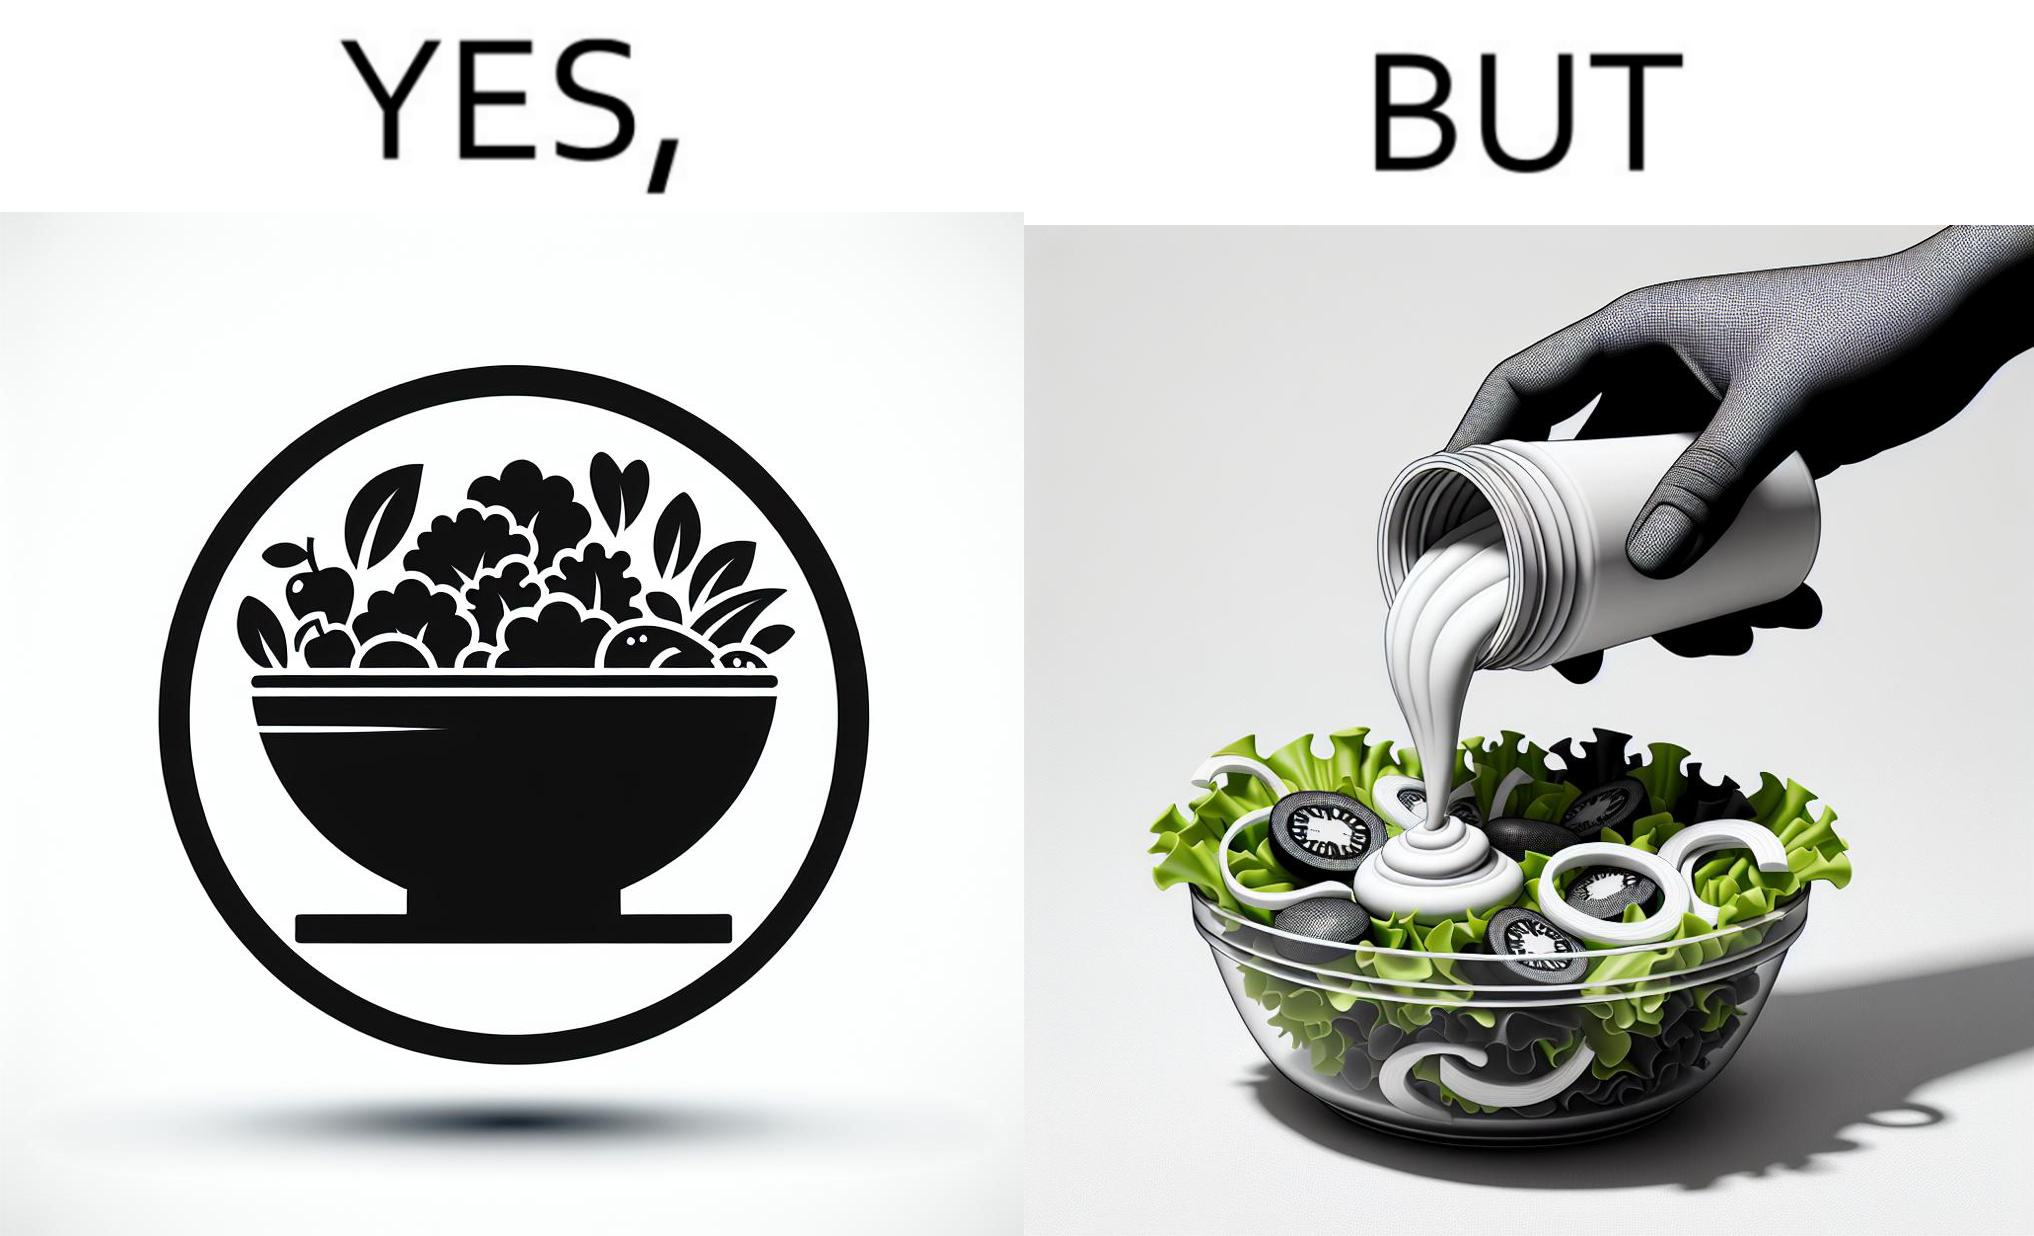Describe what you see in this image. The image is ironical, as salad in a bowl by itself is very healthy. However, when people have it with Mayonnaise sauce to improve the taste, it is not healthy anymore, and defeats the point of having nutrient-rich salad altogether. 